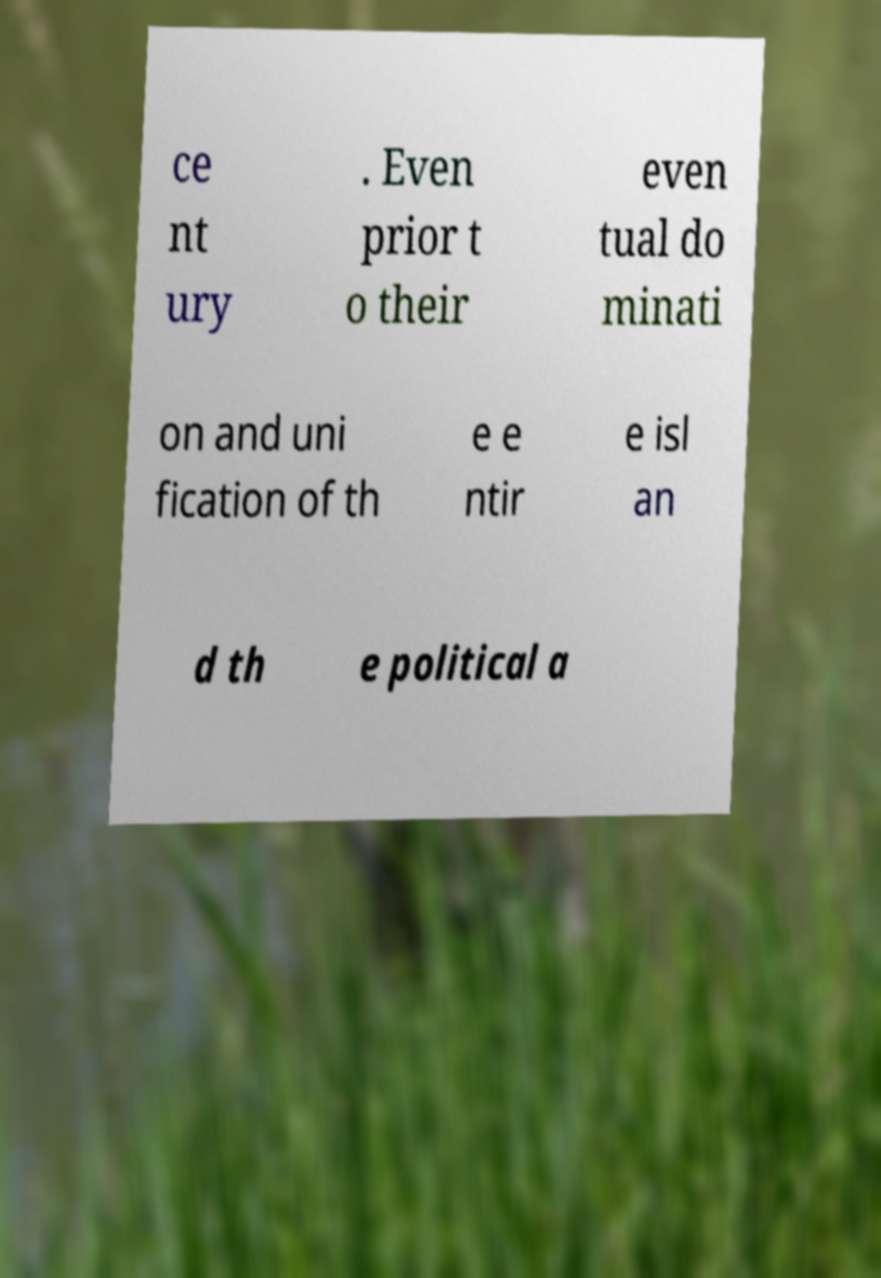Please read and relay the text visible in this image. What does it say? ce nt ury . Even prior t o their even tual do minati on and uni fication of th e e ntir e isl an d th e political a 